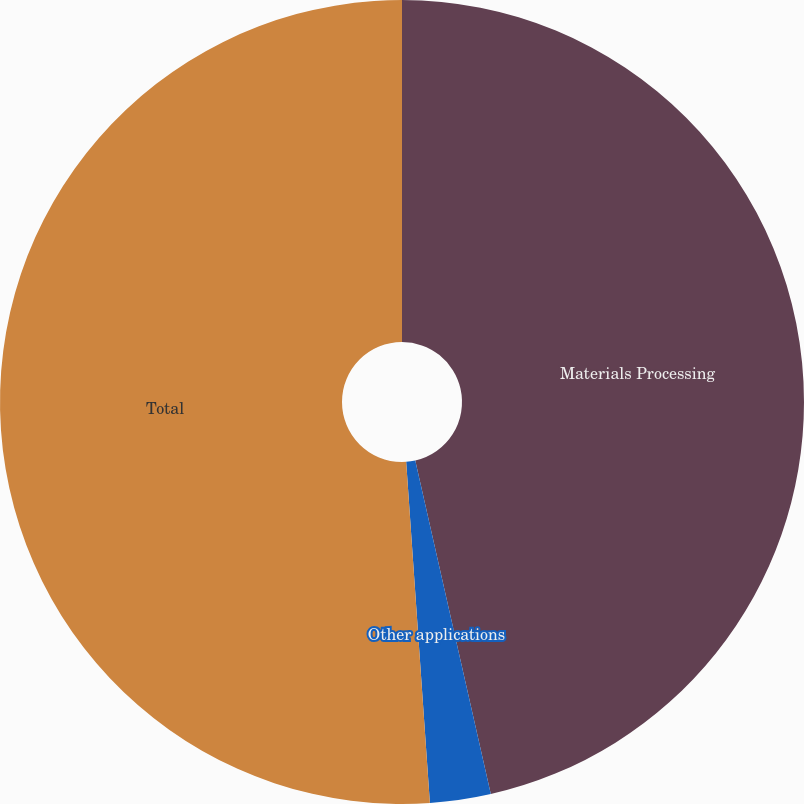Convert chart. <chart><loc_0><loc_0><loc_500><loc_500><pie_chart><fcel>Materials Processing<fcel>Other applications<fcel>Total<nl><fcel>46.45%<fcel>2.44%<fcel>51.1%<nl></chart> 